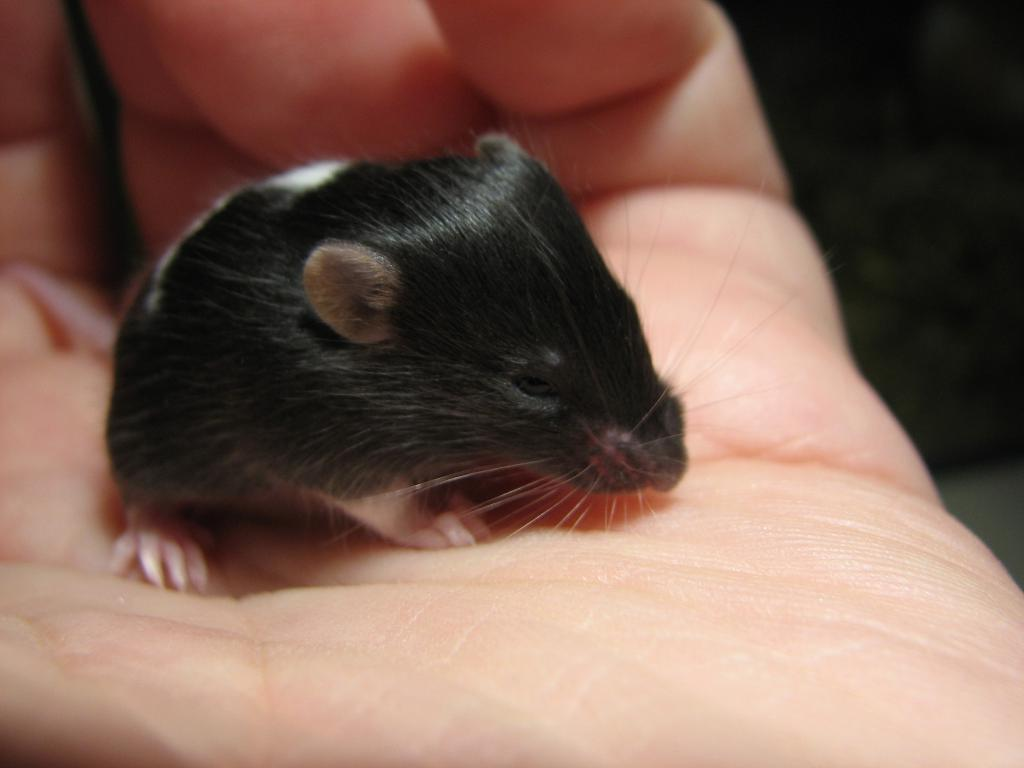What type of animal is in the image? There is a hamster in the image. How is the hamster being held in the image? The hamster is being held by a human hand. Where can the zoo be seen in the image? There is no zoo present in the image; it features a hamster being held by a human hand. What type of quill is being used to write in the image? There is no quill present in the image; it only shows a hamster being held by a human hand. 